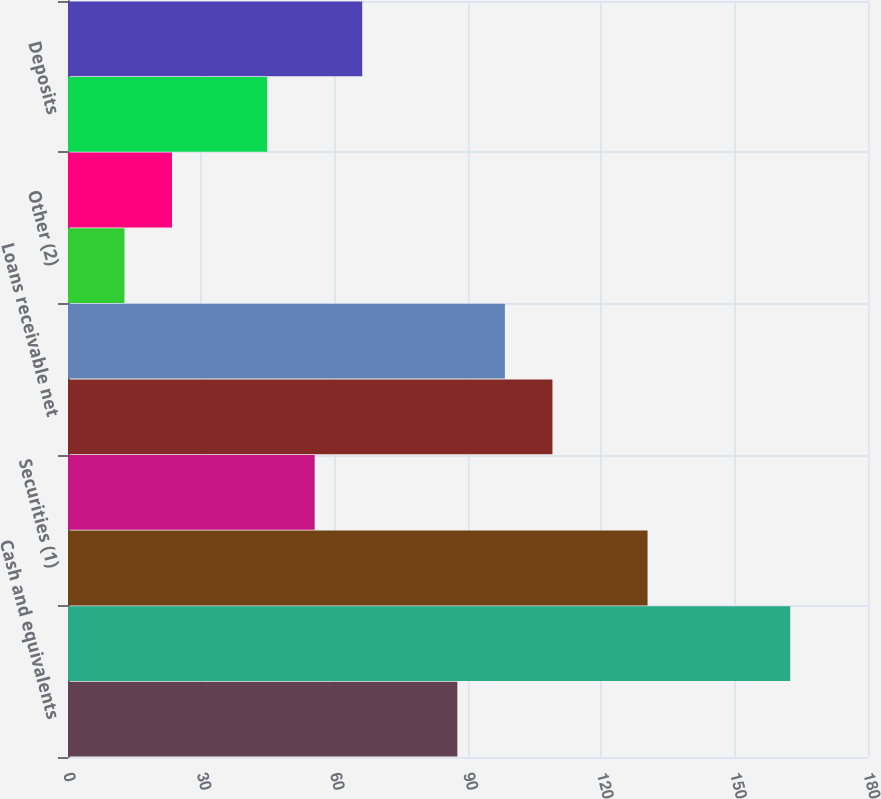<chart> <loc_0><loc_0><loc_500><loc_500><bar_chart><fcel>Cash and equivalents<fcel>Cash and investments required<fcel>Securities (1)<fcel>Margin receivables<fcel>Loans receivable net<fcel>Investment in FHLB stock<fcel>Other (2)<fcel>Total assets<fcel>Deposits<fcel>Wholesale borrowings (3)<nl><fcel>87.6<fcel>162.5<fcel>130.4<fcel>55.5<fcel>109<fcel>98.3<fcel>12.7<fcel>23.4<fcel>44.8<fcel>66.2<nl></chart> 